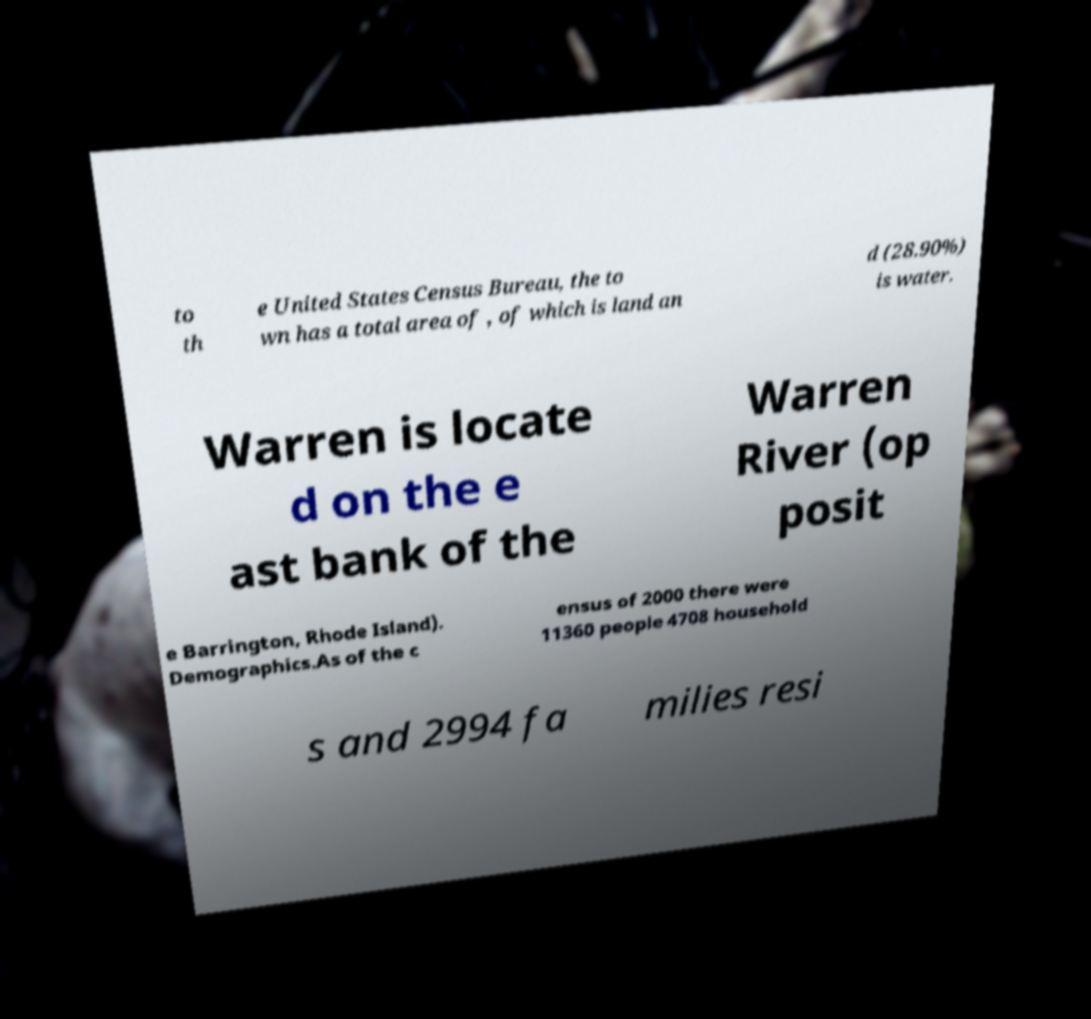Can you accurately transcribe the text from the provided image for me? to th e United States Census Bureau, the to wn has a total area of , of which is land an d (28.90%) is water. Warren is locate d on the e ast bank of the Warren River (op posit e Barrington, Rhode Island). Demographics.As of the c ensus of 2000 there were 11360 people 4708 household s and 2994 fa milies resi 